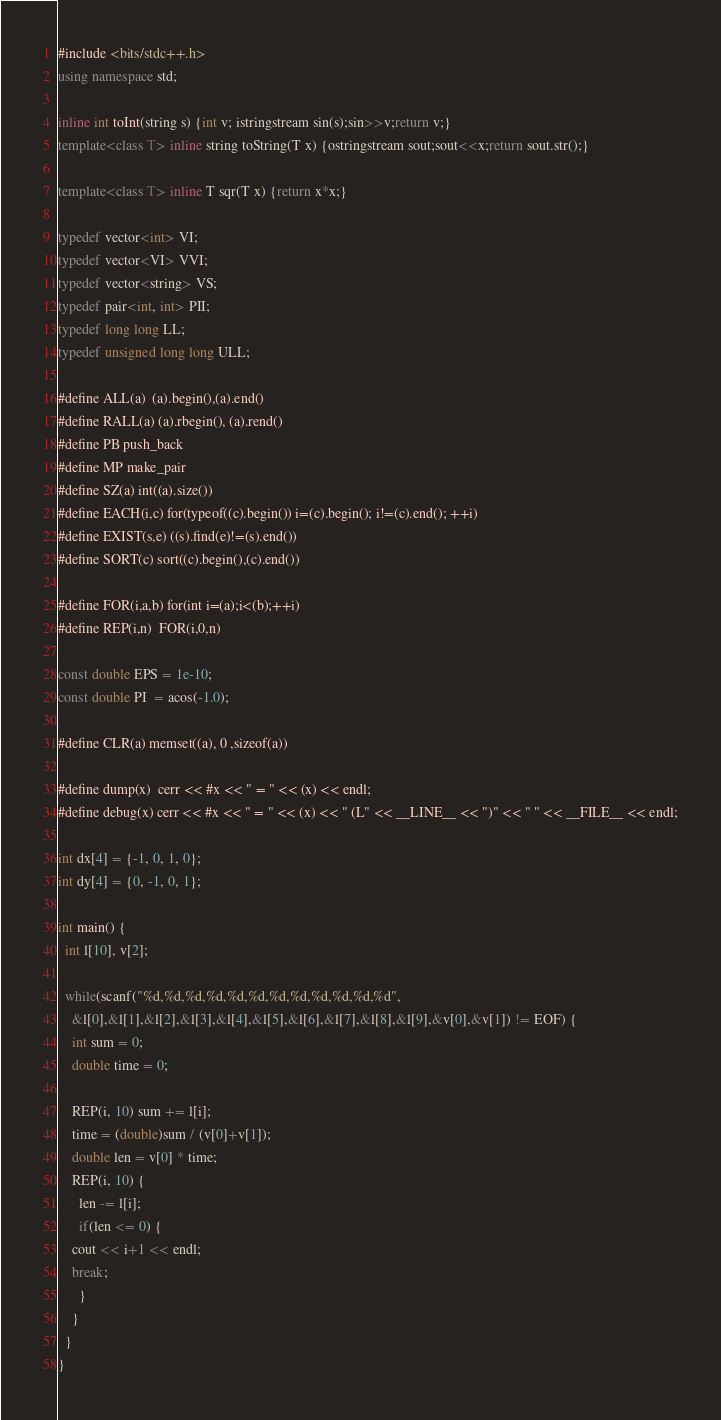Convert code to text. <code><loc_0><loc_0><loc_500><loc_500><_C++_>#include <bits/stdc++.h>
using namespace std;

inline int toInt(string s) {int v; istringstream sin(s);sin>>v;return v;}
template<class T> inline string toString(T x) {ostringstream sout;sout<<x;return sout.str();}

template<class T> inline T sqr(T x) {return x*x;}

typedef vector<int> VI;
typedef vector<VI> VVI;
typedef vector<string> VS;
typedef pair<int, int> PII;
typedef long long LL;
typedef unsigned long long ULL;

#define ALL(a)  (a).begin(),(a).end()
#define RALL(a) (a).rbegin(), (a).rend()
#define PB push_back
#define MP make_pair
#define SZ(a) int((a).size())
#define EACH(i,c) for(typeof((c).begin()) i=(c).begin(); i!=(c).end(); ++i)
#define EXIST(s,e) ((s).find(e)!=(s).end())
#define SORT(c) sort((c).begin(),(c).end())

#define FOR(i,a,b) for(int i=(a);i<(b);++i)
#define REP(i,n)  FOR(i,0,n)

const double EPS = 1e-10;
const double PI  = acos(-1.0);

#define CLR(a) memset((a), 0 ,sizeof(a))

#define dump(x)  cerr << #x << " = " << (x) << endl;
#define debug(x) cerr << #x << " = " << (x) << " (L" << __LINE__ << ")" << " " << __FILE__ << endl;

int dx[4] = {-1, 0, 1, 0};
int dy[4] = {0, -1, 0, 1};

int main() {
  int l[10], v[2];

  while(scanf("%d,%d,%d,%d,%d,%d,%d,%d,%d,%d,%d,%d",
	&l[0],&l[1],&l[2],&l[3],&l[4],&l[5],&l[6],&l[7],&l[8],&l[9],&v[0],&v[1]) != EOF) {
    int sum = 0;
    double time = 0;

    REP(i, 10) sum += l[i];
    time = (double)sum / (v[0]+v[1]);
    double len = v[0] * time;
    REP(i, 10) {
      len -= l[i];
      if(len <= 0) {
	cout << i+1 << endl;
	break;
      }
    }
  }
}</code> 